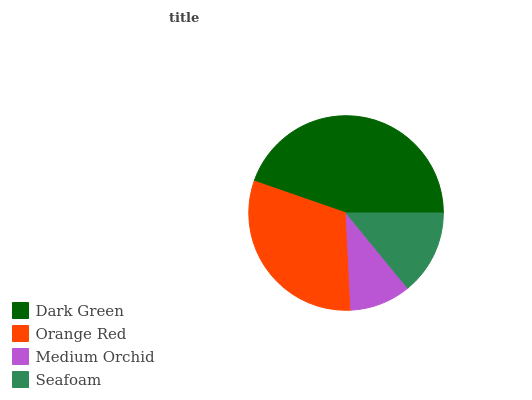Is Medium Orchid the minimum?
Answer yes or no. Yes. Is Dark Green the maximum?
Answer yes or no. Yes. Is Orange Red the minimum?
Answer yes or no. No. Is Orange Red the maximum?
Answer yes or no. No. Is Dark Green greater than Orange Red?
Answer yes or no. Yes. Is Orange Red less than Dark Green?
Answer yes or no. Yes. Is Orange Red greater than Dark Green?
Answer yes or no. No. Is Dark Green less than Orange Red?
Answer yes or no. No. Is Orange Red the high median?
Answer yes or no. Yes. Is Seafoam the low median?
Answer yes or no. Yes. Is Seafoam the high median?
Answer yes or no. No. Is Medium Orchid the low median?
Answer yes or no. No. 